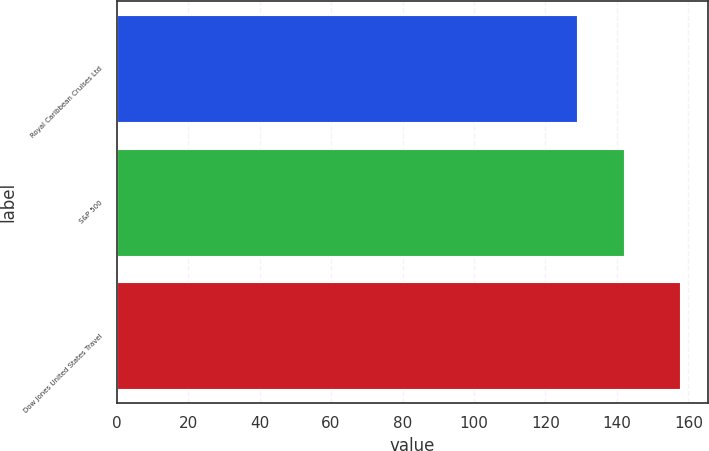<chart> <loc_0><loc_0><loc_500><loc_500><bar_chart><fcel>Royal Caribbean Cruises Ltd<fcel>S&P 500<fcel>Dow Jones United States Travel<nl><fcel>128.7<fcel>142.1<fcel>157.71<nl></chart> 